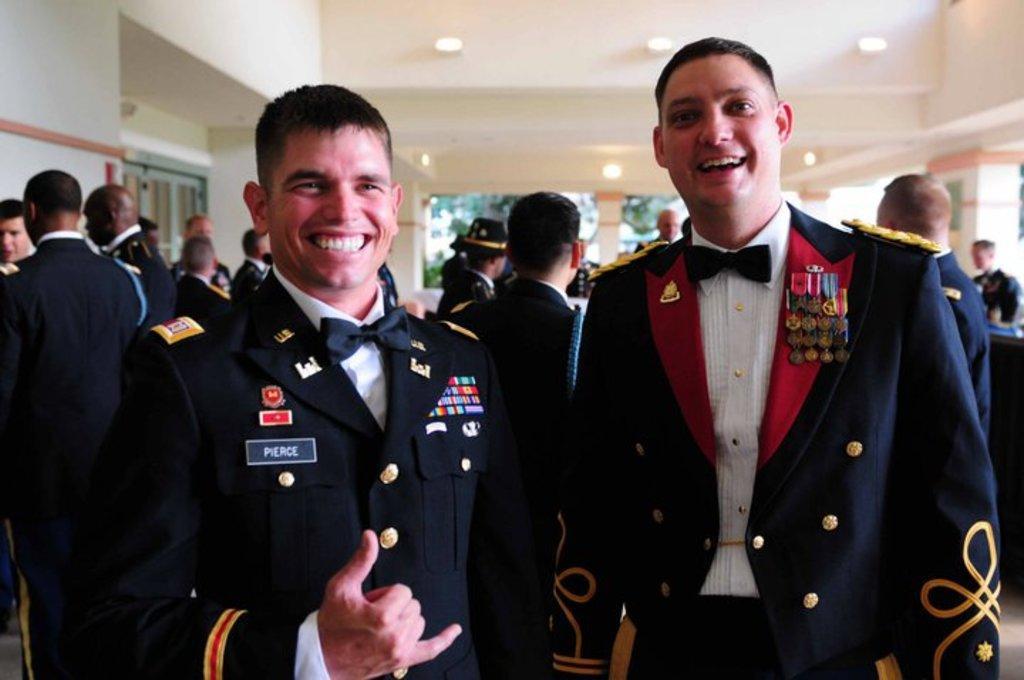Could you give a brief overview of what you see in this image? In this image I can see two persons wearing a blue color jackets they are standing and they are smiling and in the foreground and in the background I can see few persons, at the top I can see the wall. 